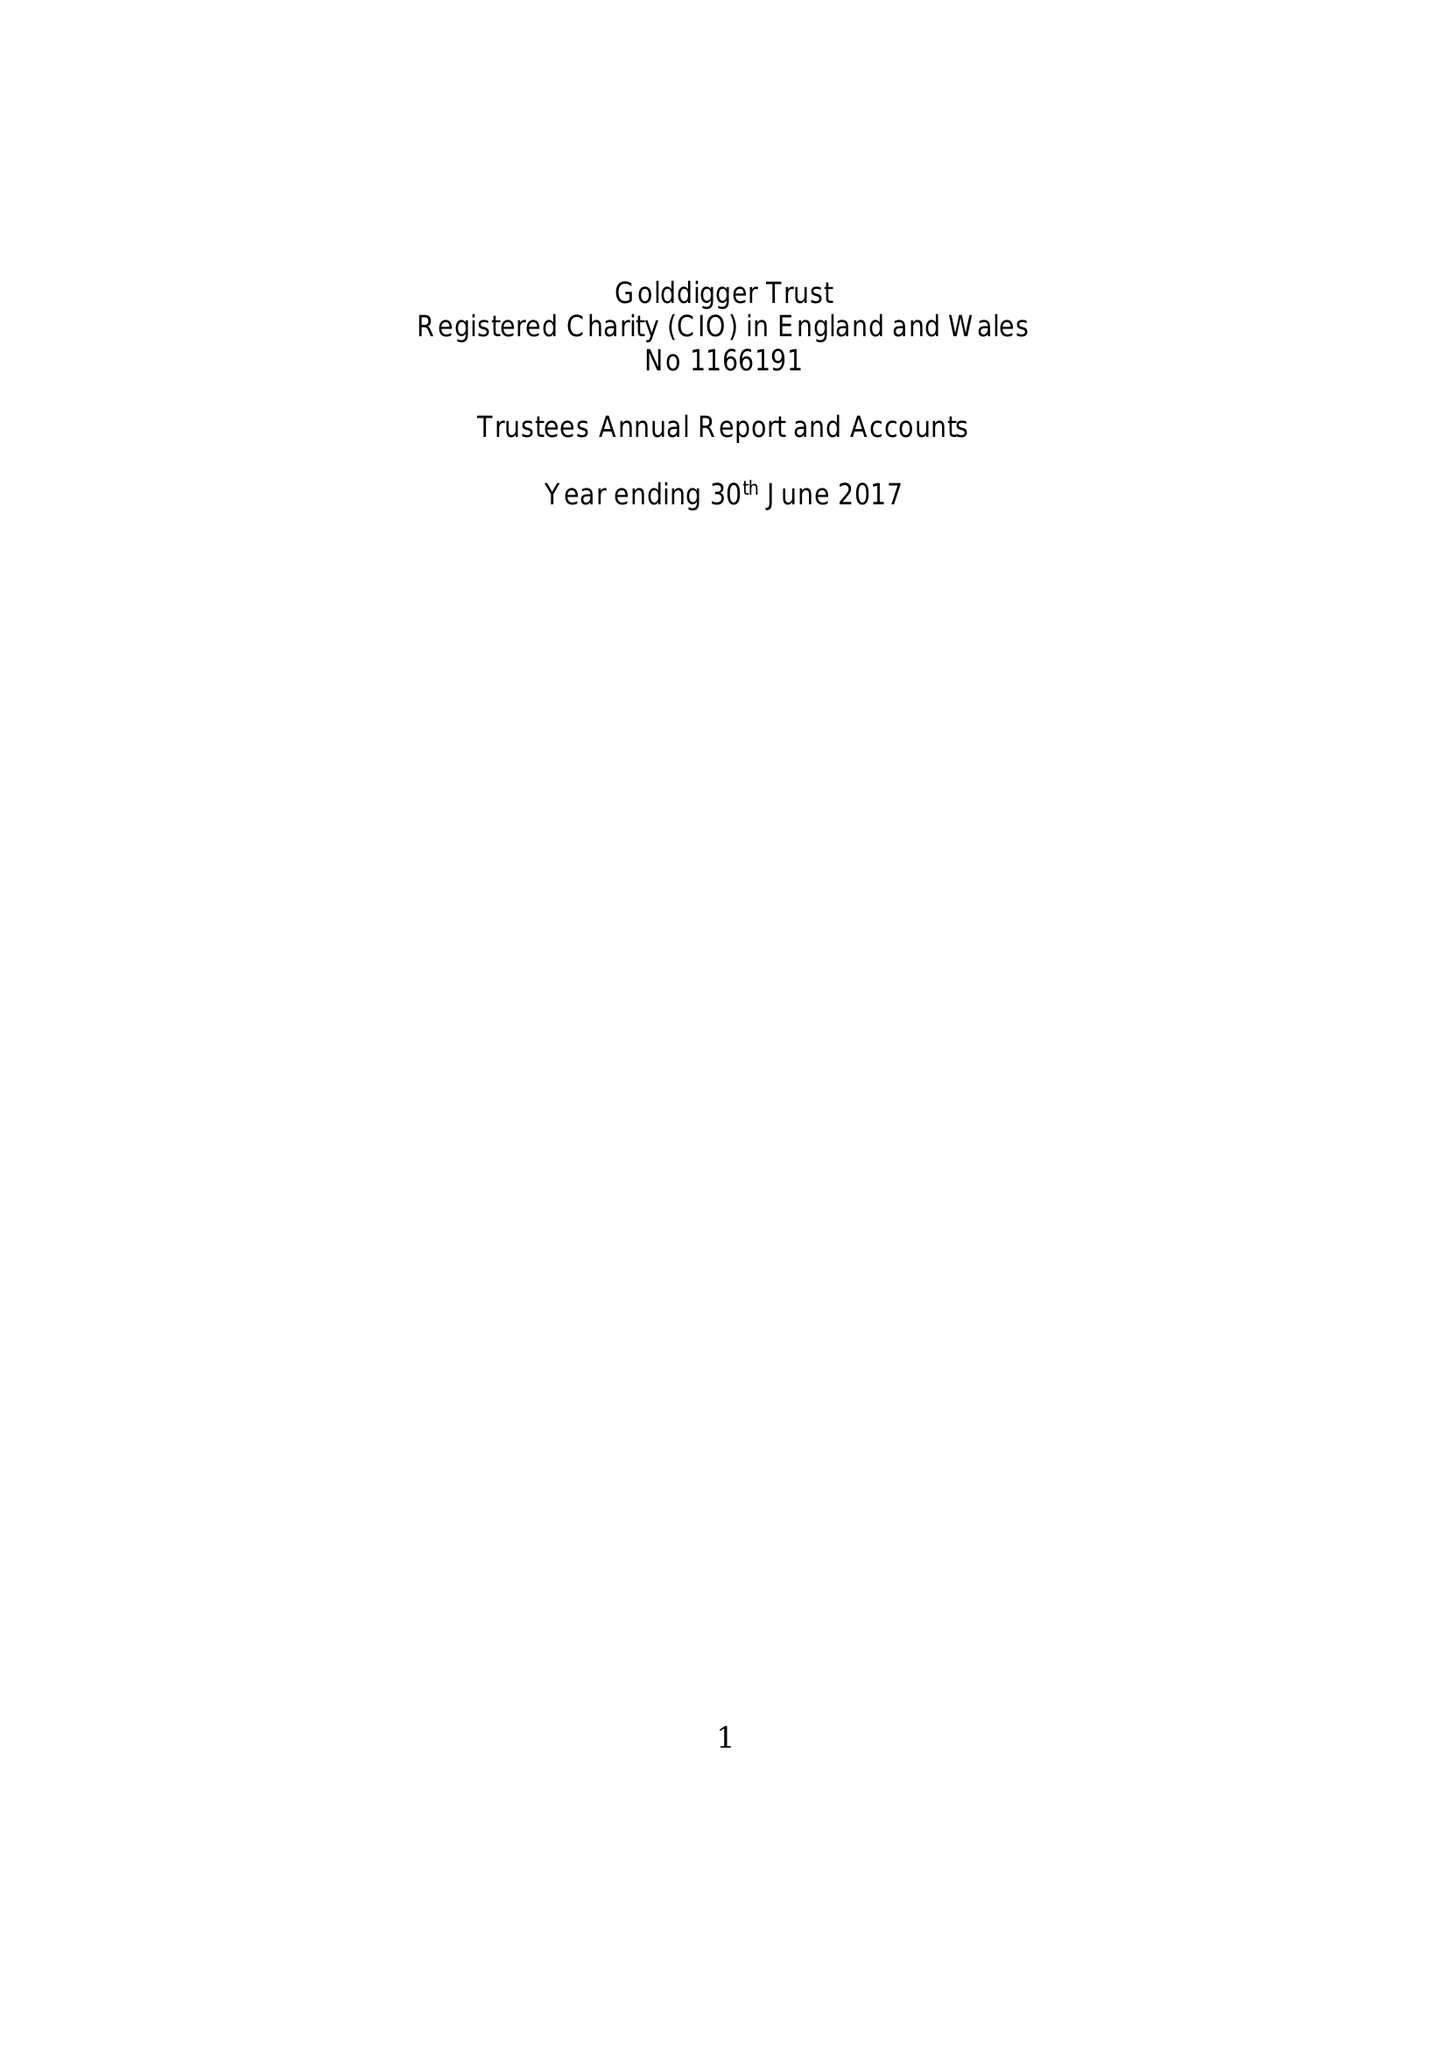What is the value for the income_annually_in_british_pounds?
Answer the question using a single word or phrase. 136381.00 